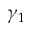Convert formula to latex. <formula><loc_0><loc_0><loc_500><loc_500>\gamma _ { 1 }</formula> 